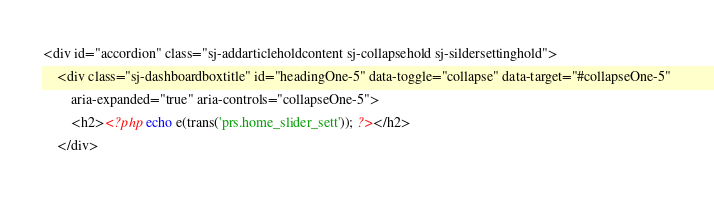Convert code to text. <code><loc_0><loc_0><loc_500><loc_500><_PHP_><div id="accordion" class="sj-addarticleholdcontent sj-collapsehold sj-sildersettinghold">
    <div class="sj-dashboardboxtitle" id="headingOne-5" data-toggle="collapse" data-target="#collapseOne-5"
        aria-expanded="true" aria-controls="collapseOne-5">
        <h2><?php echo e(trans('prs.home_slider_sett')); ?></h2>
    </div></code> 